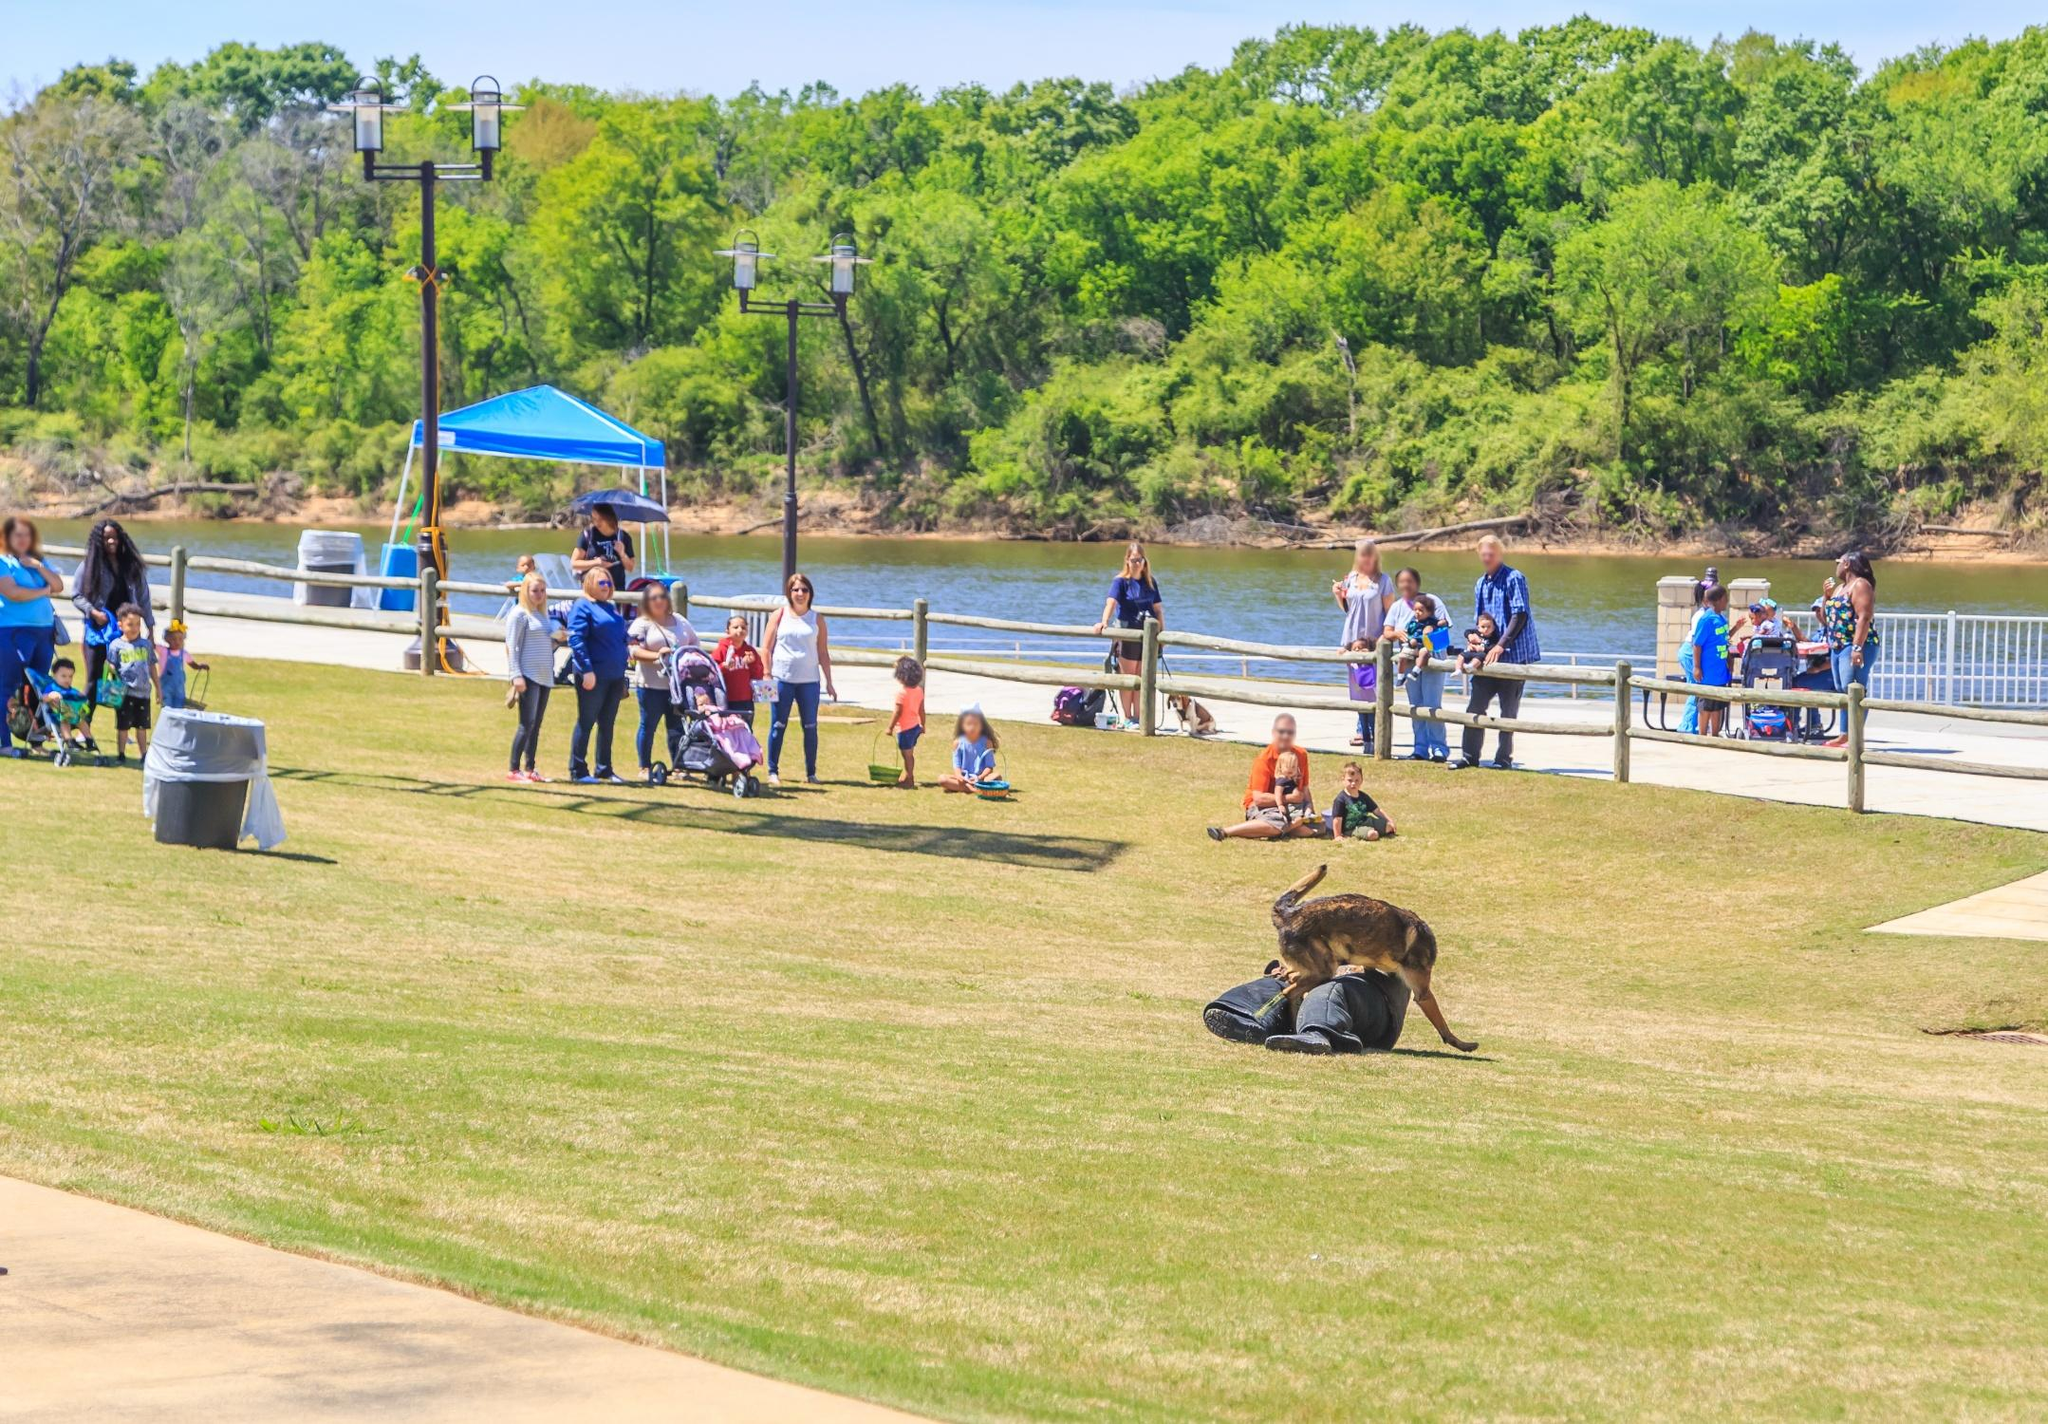Imagine a conversation between two park-goers in this setting. Person A: "What a beautiful day! I’m so glad we decided to come to the park."

Person B: "I know, right? The weather is perfect and look at how happy the kids are running around."

Person A: "Did you see the dog over there sniffing that backpack? It's hilarious!"

Person B: "Yes, it seems to be having the time of its life! By the way, we should find a spot under that blue canopy to rest for a while."

Person A: "Great idea, let’s head over there and enjoy the shade." 